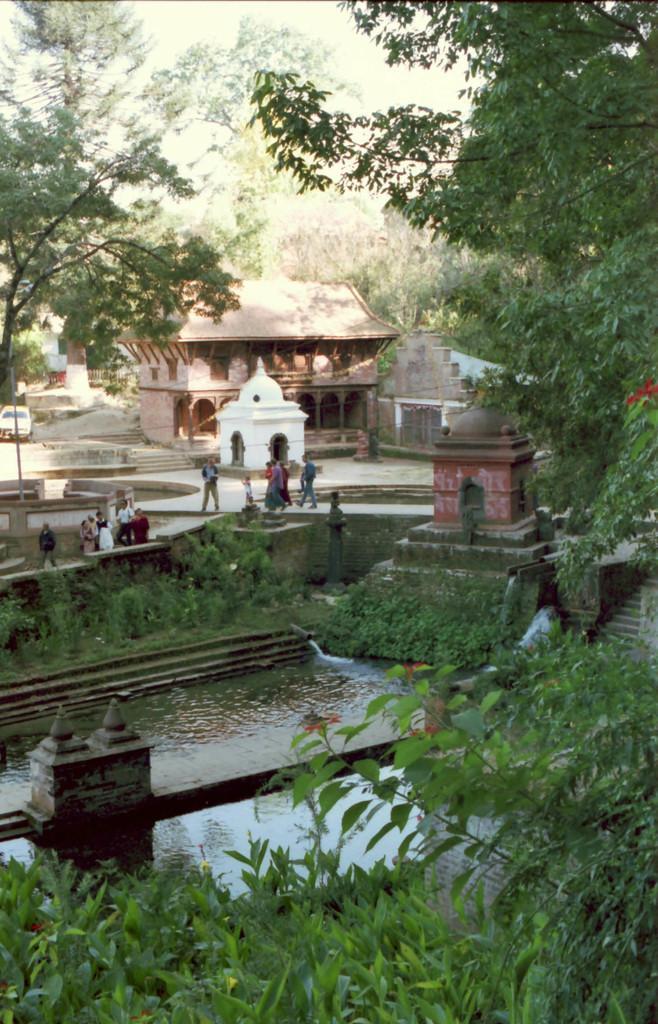Could you give a brief overview of what you see in this image? In this image, we can see a lake. There is a building in the middle of the image. There is a tree in the top left and in the top right of the image. There are some leaves at the bottom of the image. 